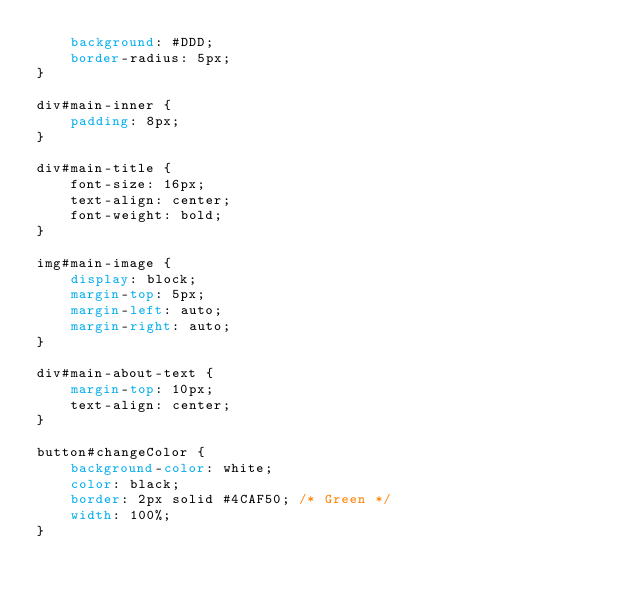Convert code to text. <code><loc_0><loc_0><loc_500><loc_500><_CSS_>    background: #DDD;
    border-radius: 5px;
}

div#main-inner {
    padding: 8px;
}

div#main-title {
    font-size: 16px;
    text-align: center;
    font-weight: bold;
}

img#main-image {
    display: block;
    margin-top: 5px;
    margin-left: auto;
    margin-right: auto;
}

div#main-about-text {
    margin-top: 10px;
    text-align: center;
}

button#changeColor {
    background-color: white;
    color: black;
    border: 2px solid #4CAF50; /* Green */
    width: 100%;
}</code> 